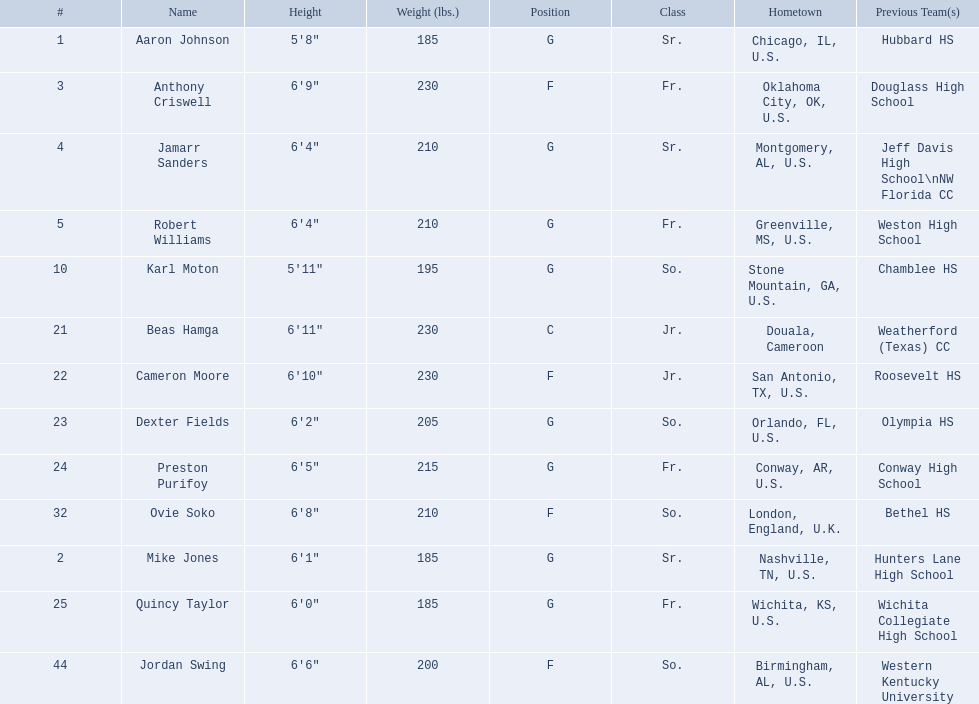Which are all of the players? Aaron Johnson, Anthony Criswell, Jamarr Sanders, Robert Williams, Karl Moton, Beas Hamga, Cameron Moore, Dexter Fields, Preston Purifoy, Ovie Soko, Mike Jones, Quincy Taylor, Jordan Swing. Which players are from a country outside of the u.s.? Beas Hamga, Ovie Soko. Aside from soko, who else is not from the u.s.? Beas Hamga. 